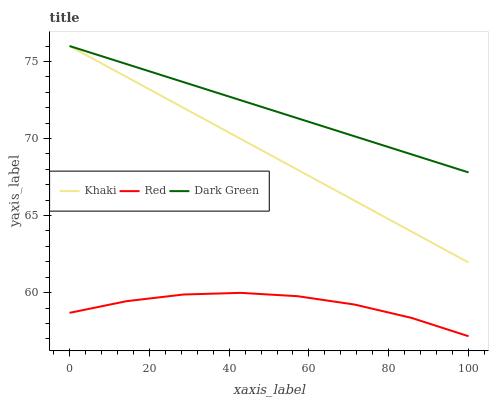Does Dark Green have the minimum area under the curve?
Answer yes or no. No. Does Red have the maximum area under the curve?
Answer yes or no. No. Is Dark Green the smoothest?
Answer yes or no. No. Is Dark Green the roughest?
Answer yes or no. No. Does Dark Green have the lowest value?
Answer yes or no. No. Does Red have the highest value?
Answer yes or no. No. Is Red less than Khaki?
Answer yes or no. Yes. Is Dark Green greater than Red?
Answer yes or no. Yes. Does Red intersect Khaki?
Answer yes or no. No. 